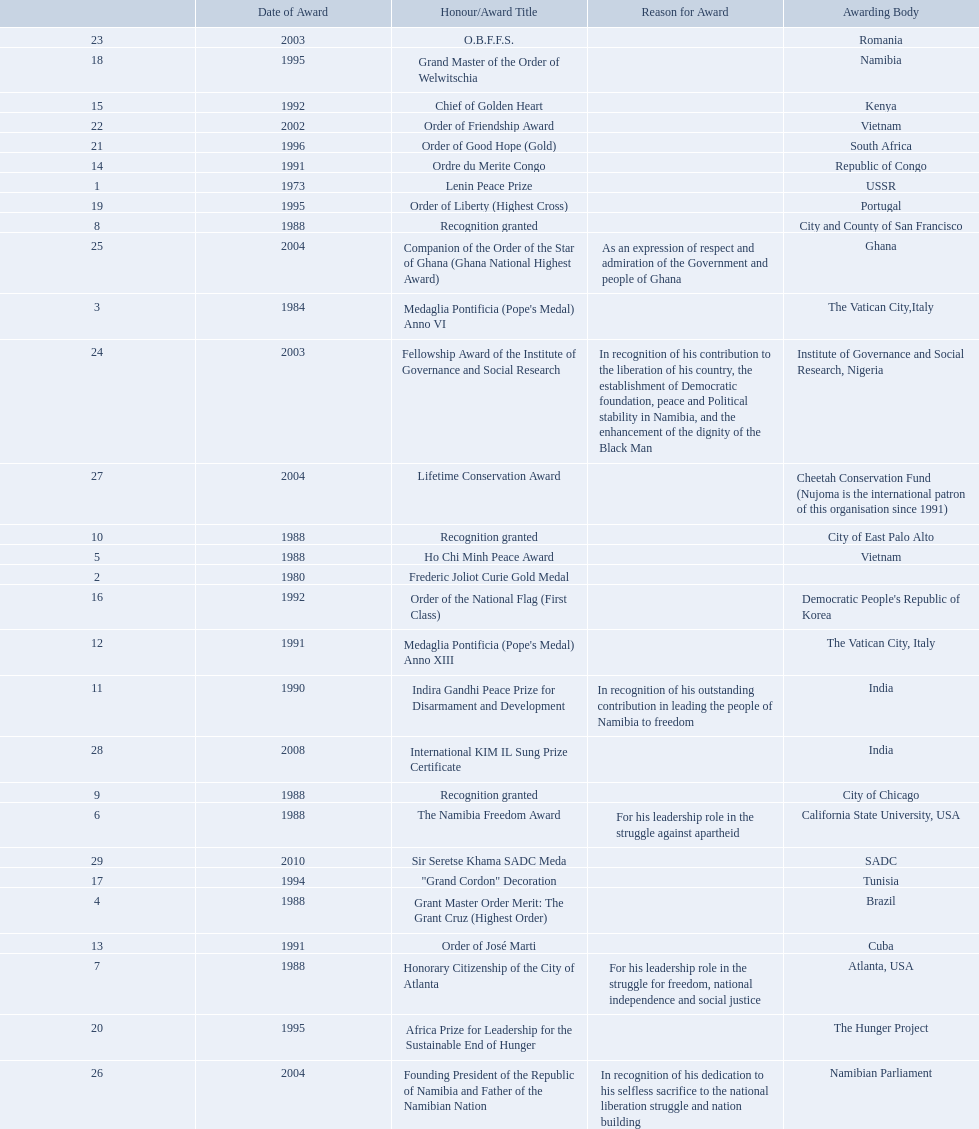Could you help me parse every detail presented in this table? {'header': ['', 'Date of Award', 'Honour/Award Title', 'Reason for Award', 'Awarding Body'], 'rows': [['23', '2003', 'O.B.F.F.S.', '', 'Romania'], ['18', '1995', 'Grand Master of the Order of Welwitschia', '', 'Namibia'], ['15', '1992', 'Chief of Golden Heart', '', 'Kenya'], ['22', '2002', 'Order of Friendship Award', '', 'Vietnam'], ['21', '1996', 'Order of Good Hope (Gold)', '', 'South Africa'], ['14', '1991', 'Ordre du Merite Congo', '', 'Republic of Congo'], ['1', '1973', 'Lenin Peace Prize', '', 'USSR'], ['19', '1995', 'Order of Liberty (Highest Cross)', '', 'Portugal'], ['8', '1988', 'Recognition granted', '', 'City and County of San Francisco'], ['25', '2004', 'Companion of the Order of the Star of Ghana (Ghana National Highest Award)', 'As an expression of respect and admiration of the Government and people of Ghana', 'Ghana'], ['3', '1984', "Medaglia Pontificia (Pope's Medal) Anno VI", '', 'The Vatican City,Italy'], ['24', '2003', 'Fellowship Award of the Institute of Governance and Social Research', 'In recognition of his contribution to the liberation of his country, the establishment of Democratic foundation, peace and Political stability in Namibia, and the enhancement of the dignity of the Black Man', 'Institute of Governance and Social Research, Nigeria'], ['27', '2004', 'Lifetime Conservation Award', '', 'Cheetah Conservation Fund (Nujoma is the international patron of this organisation since 1991)'], ['10', '1988', 'Recognition granted', '', 'City of East Palo Alto'], ['5', '1988', 'Ho Chi Minh Peace Award', '', 'Vietnam'], ['2', '1980', 'Frederic Joliot Curie Gold Medal', '', ''], ['16', '1992', 'Order of the National Flag (First Class)', '', "Democratic People's Republic of Korea"], ['12', '1991', "Medaglia Pontificia (Pope's Medal) Anno XIII", '', 'The Vatican City, Italy'], ['11', '1990', 'Indira Gandhi Peace Prize for Disarmament and Development', 'In recognition of his outstanding contribution in leading the people of Namibia to freedom', 'India'], ['28', '2008', 'International KIM IL Sung Prize Certificate', '', 'India'], ['9', '1988', 'Recognition granted', '', 'City of Chicago'], ['6', '1988', 'The Namibia Freedom Award', 'For his leadership role in the struggle against apartheid', 'California State University, USA'], ['29', '2010', 'Sir Seretse Khama SADC Meda', '', 'SADC'], ['17', '1994', '"Grand Cordon" Decoration', '', 'Tunisia'], ['4', '1988', 'Grant Master Order Merit: The Grant Cruz (Highest Order)', '', 'Brazil'], ['13', '1991', 'Order of José Marti', '', 'Cuba'], ['7', '1988', 'Honorary Citizenship of the City of Atlanta', 'For his leadership role in the struggle for freedom, national independence and social justice', 'Atlanta, USA'], ['20', '1995', 'Africa Prize for Leadership for the Sustainable End of Hunger', '', 'The Hunger Project'], ['26', '2004', 'Founding President of the Republic of Namibia and Father of the Namibian Nation', 'In recognition of his dedication to his selfless sacrifice to the national liberation struggle and nation building', 'Namibian Parliament']]} What awards has sam nujoma been awarded? Lenin Peace Prize, Frederic Joliot Curie Gold Medal, Medaglia Pontificia (Pope's Medal) Anno VI, Grant Master Order Merit: The Grant Cruz (Highest Order), Ho Chi Minh Peace Award, The Namibia Freedom Award, Honorary Citizenship of the City of Atlanta, Recognition granted, Recognition granted, Recognition granted, Indira Gandhi Peace Prize for Disarmament and Development, Medaglia Pontificia (Pope's Medal) Anno XIII, Order of José Marti, Ordre du Merite Congo, Chief of Golden Heart, Order of the National Flag (First Class), "Grand Cordon" Decoration, Grand Master of the Order of Welwitschia, Order of Liberty (Highest Cross), Africa Prize for Leadership for the Sustainable End of Hunger, Order of Good Hope (Gold), Order of Friendship Award, O.B.F.F.S., Fellowship Award of the Institute of Governance and Social Research, Companion of the Order of the Star of Ghana (Ghana National Highest Award), Founding President of the Republic of Namibia and Father of the Namibian Nation, Lifetime Conservation Award, International KIM IL Sung Prize Certificate, Sir Seretse Khama SADC Meda. By which awarding body did sam nujoma receive the o.b.f.f.s award? Romania. 